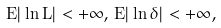Convert formula to latex. <formula><loc_0><loc_0><loc_500><loc_500>E | \ln L | < + \infty , \, E | \ln \delta | < + \infty ,</formula> 